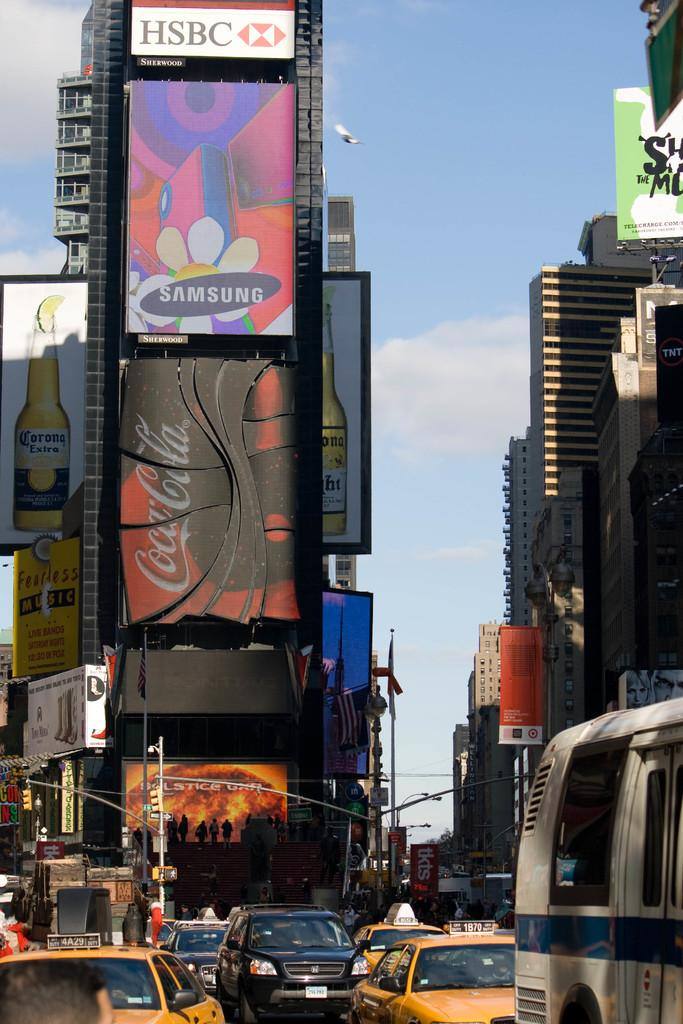<image>
Give a short and clear explanation of the subsequent image. A city scene showing buildings displaying billboards advertising for HSBC, Samsung and Coca-Cola. 